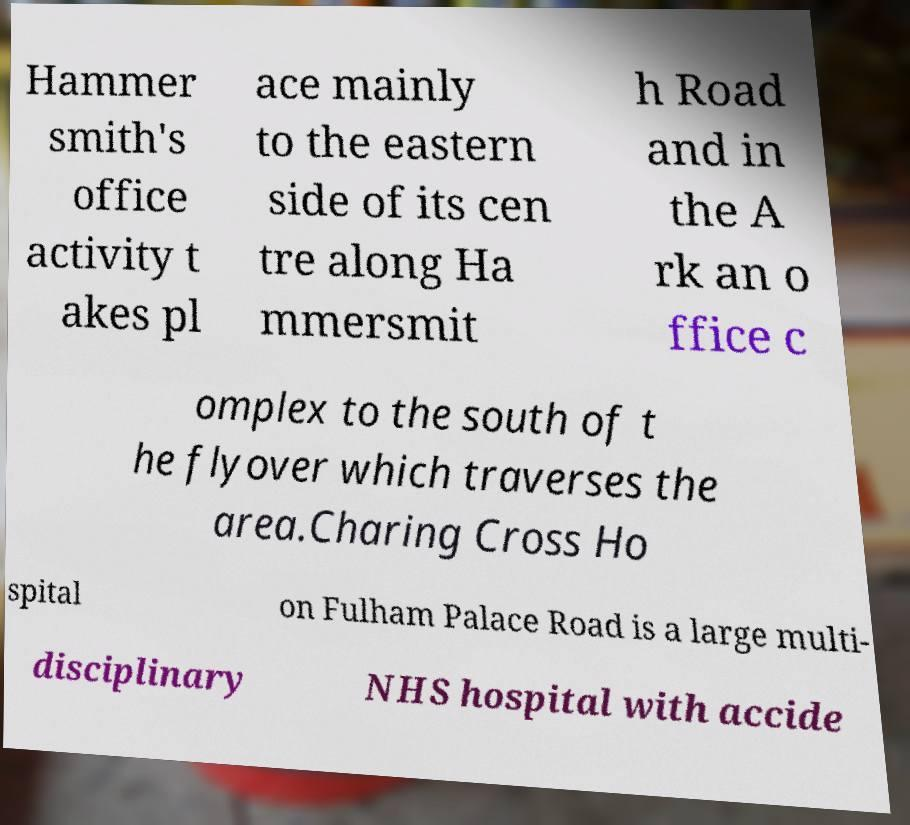Could you extract and type out the text from this image? Hammer smith's office activity t akes pl ace mainly to the eastern side of its cen tre along Ha mmersmit h Road and in the A rk an o ffice c omplex to the south of t he flyover which traverses the area.Charing Cross Ho spital on Fulham Palace Road is a large multi- disciplinary NHS hospital with accide 